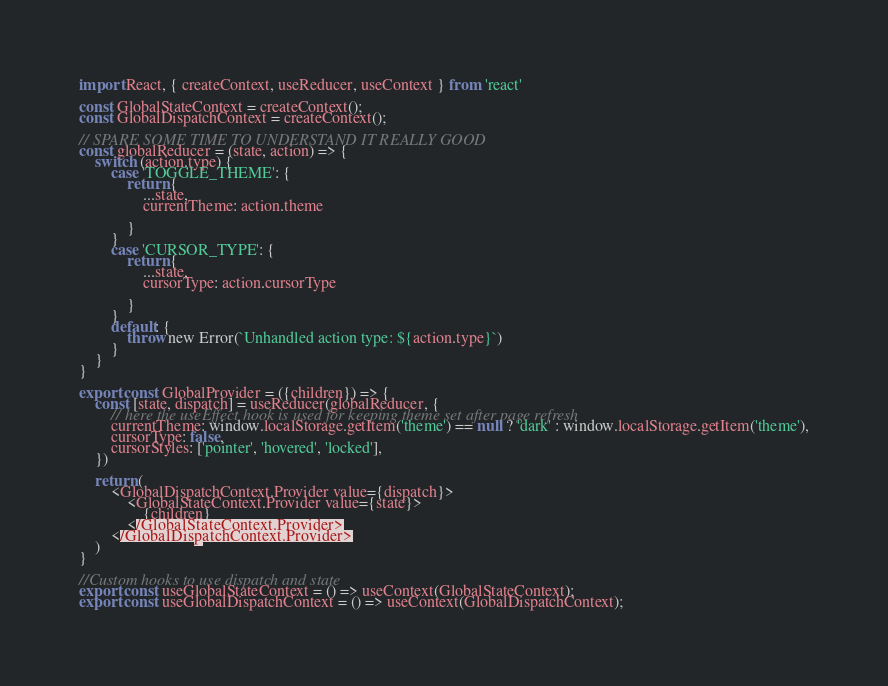<code> <loc_0><loc_0><loc_500><loc_500><_JavaScript_>import React, { createContext, useReducer, useContext } from 'react'

const GlobalStateContext = createContext();
const GlobalDispatchContext = createContext();

// SPARE SOME TIME TO UNDERSTAND IT REALLY GOOD
const globalReducer = (state, action) => {
    switch (action.type) {
        case 'TOGGLE_THEME': {
            return {
                ...state,
                currentTheme: action.theme

            }
        }
        case 'CURSOR_TYPE': {
            return {
                ...state,
                cursorType: action.cursorType

            }
        }
        default: {
            throw new Error(`Unhandled action type: ${action.type}`)
        }
    }
}

export const GlobalProvider = ({children}) => {
    const [state, dispatch] = useReducer(globalReducer, {
        // here the useEffect hook is used for keeping theme set after page refresh
        currentTheme: window.localStorage.getItem('theme') == null ? 'dark' : window.localStorage.getItem('theme'),
        cursorType: false,
        cursorStyles: ['pointer', 'hovered', 'locked'],
    })

    return (
        <GlobalDispatchContext.Provider value={dispatch}>
            <GlobalStateContext.Provider value={state}>
                {children}
            </GlobalStateContext.Provider>
        </GlobalDispatchContext.Provider>
    )
}

//Custom hooks to use dispatch and state
export const useGlobalStateContext = () => useContext(GlobalStateContext);
export const useGlobalDispatchContext = () => useContext(GlobalDispatchContext);</code> 